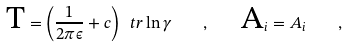<formula> <loc_0><loc_0><loc_500><loc_500>\text {T} = \left ( \frac { 1 } { 2 \pi \epsilon } + c \right ) \ t r \ln \gamma \quad , \quad \text {A} _ { i } = A _ { i } \quad ,</formula> 